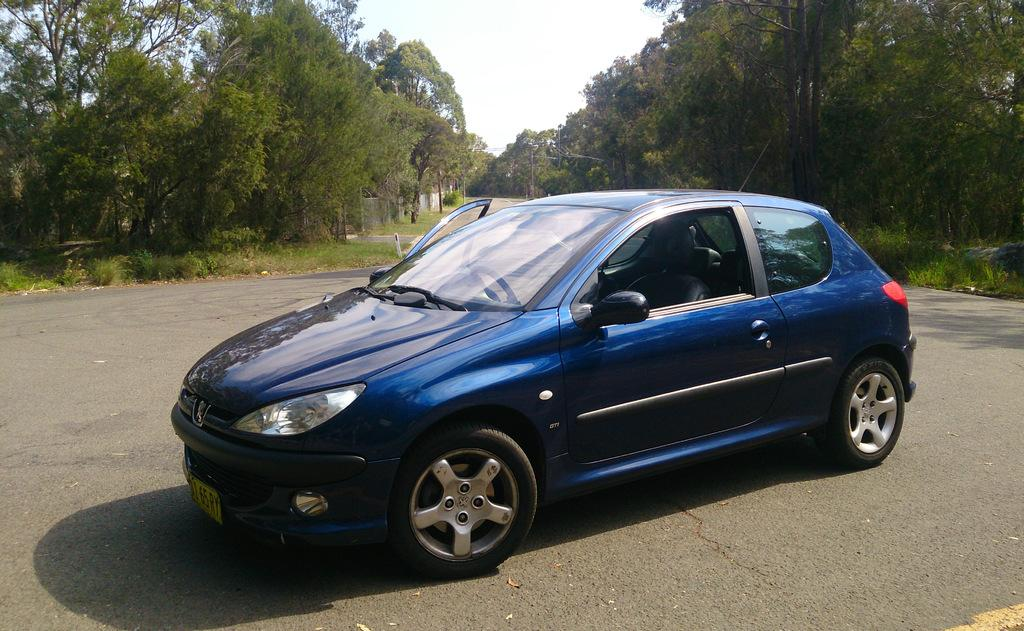What color is the car in the image? The car in the image is blue. Where is the car located? The car is on the road. What can be seen on either side of the car? There are trees on either side of the car. What is visible above the car? The sky is visible above the car. How many rabbits are hopping around the car in the image? There are no rabbits present in the image. Is the car driving through a rainstorm in the image? The image does not depict a rainstorm; the sky is visible above the car, and there is no indication of rain. 